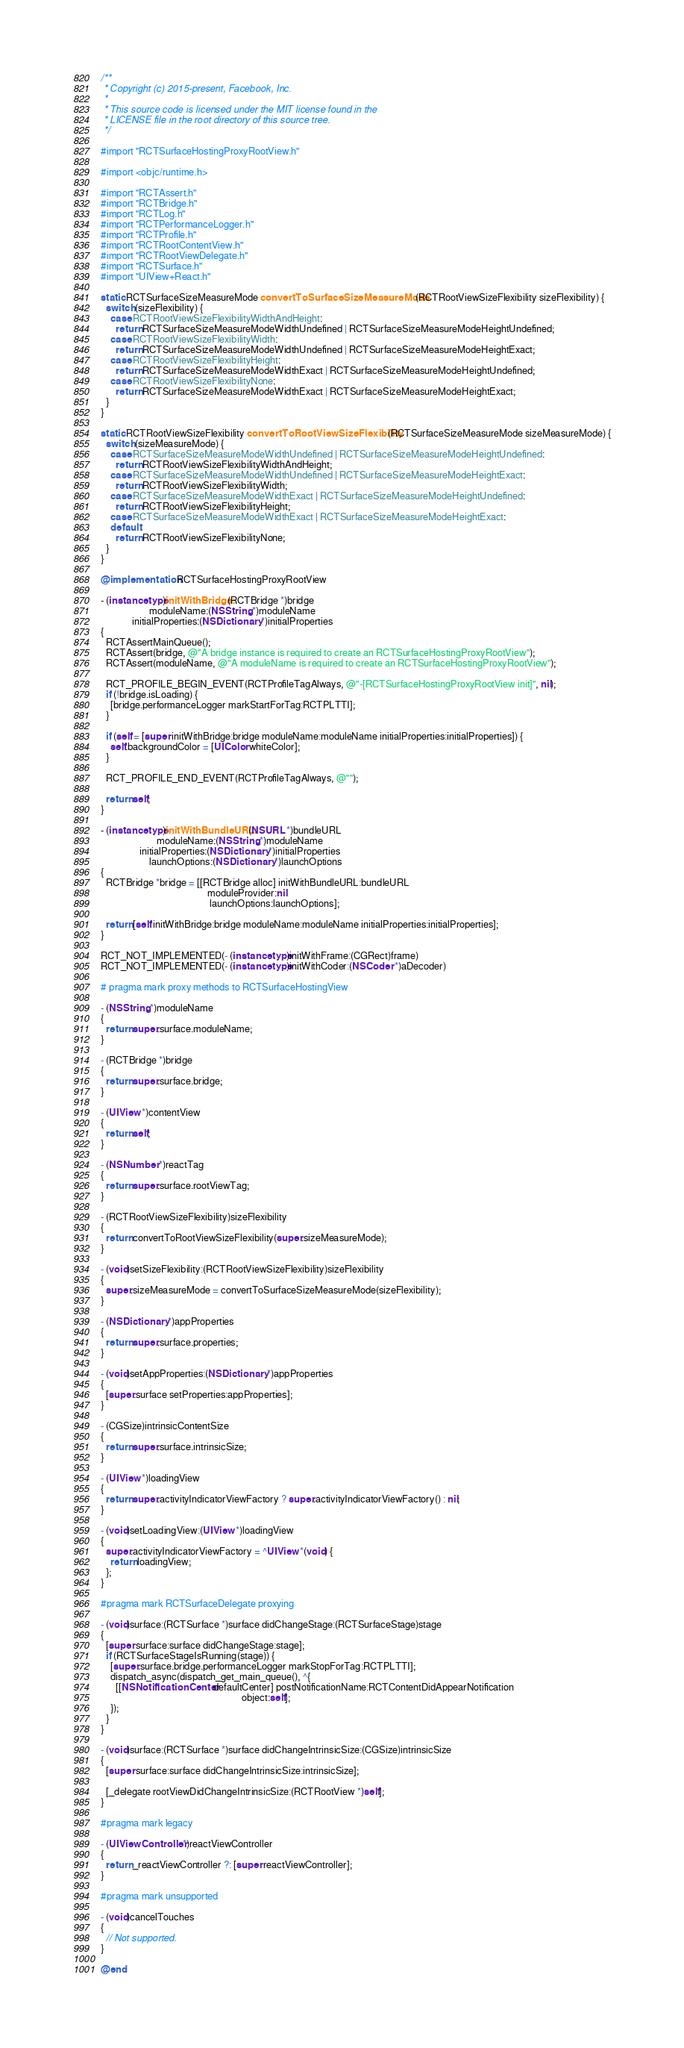<code> <loc_0><loc_0><loc_500><loc_500><_ObjectiveC_>/**
 * Copyright (c) 2015-present, Facebook, Inc.
 *
 * This source code is licensed under the MIT license found in the
 * LICENSE file in the root directory of this source tree.
 */

#import "RCTSurfaceHostingProxyRootView.h"

#import <objc/runtime.h>

#import "RCTAssert.h"
#import "RCTBridge.h"
#import "RCTLog.h"
#import "RCTPerformanceLogger.h"
#import "RCTProfile.h"
#import "RCTRootContentView.h"
#import "RCTRootViewDelegate.h"
#import "RCTSurface.h"
#import "UIView+React.h"

static RCTSurfaceSizeMeasureMode convertToSurfaceSizeMeasureMode(RCTRootViewSizeFlexibility sizeFlexibility) {
  switch (sizeFlexibility) {
    case RCTRootViewSizeFlexibilityWidthAndHeight:
      return RCTSurfaceSizeMeasureModeWidthUndefined | RCTSurfaceSizeMeasureModeHeightUndefined;
    case RCTRootViewSizeFlexibilityWidth:
      return RCTSurfaceSizeMeasureModeWidthUndefined | RCTSurfaceSizeMeasureModeHeightExact;
    case RCTRootViewSizeFlexibilityHeight:
      return RCTSurfaceSizeMeasureModeWidthExact | RCTSurfaceSizeMeasureModeHeightUndefined;
    case RCTRootViewSizeFlexibilityNone:
      return RCTSurfaceSizeMeasureModeWidthExact | RCTSurfaceSizeMeasureModeHeightExact;
  }
}

static RCTRootViewSizeFlexibility convertToRootViewSizeFlexibility(RCTSurfaceSizeMeasureMode sizeMeasureMode) {
  switch (sizeMeasureMode) {
    case RCTSurfaceSizeMeasureModeWidthUndefined | RCTSurfaceSizeMeasureModeHeightUndefined:
      return RCTRootViewSizeFlexibilityWidthAndHeight;
    case RCTSurfaceSizeMeasureModeWidthUndefined | RCTSurfaceSizeMeasureModeHeightExact:
      return RCTRootViewSizeFlexibilityWidth;
    case RCTSurfaceSizeMeasureModeWidthExact | RCTSurfaceSizeMeasureModeHeightUndefined:
      return RCTRootViewSizeFlexibilityHeight;
    case RCTSurfaceSizeMeasureModeWidthExact | RCTSurfaceSizeMeasureModeHeightExact:
    default:
      return RCTRootViewSizeFlexibilityNone;
  }
}

@implementation RCTSurfaceHostingProxyRootView

- (instancetype)initWithBridge:(RCTBridge *)bridge
                    moduleName:(NSString *)moduleName
             initialProperties:(NSDictionary *)initialProperties
{
  RCTAssertMainQueue();
  RCTAssert(bridge, @"A bridge instance is required to create an RCTSurfaceHostingProxyRootView");
  RCTAssert(moduleName, @"A moduleName is required to create an RCTSurfaceHostingProxyRootView");

  RCT_PROFILE_BEGIN_EVENT(RCTProfileTagAlways, @"-[RCTSurfaceHostingProxyRootView init]", nil);
  if (!bridge.isLoading) {
    [bridge.performanceLogger markStartForTag:RCTPLTTI];
  }

  if (self = [super initWithBridge:bridge moduleName:moduleName initialProperties:initialProperties]) {
    self.backgroundColor = [UIColor whiteColor];
  }

  RCT_PROFILE_END_EVENT(RCTProfileTagAlways, @"");

  return self;
}

- (instancetype)initWithBundleURL:(NSURL *)bundleURL
                       moduleName:(NSString *)moduleName
                initialProperties:(NSDictionary *)initialProperties
                    launchOptions:(NSDictionary *)launchOptions
{
  RCTBridge *bridge = [[RCTBridge alloc] initWithBundleURL:bundleURL
                                            moduleProvider:nil
                                             launchOptions:launchOptions];

  return [self initWithBridge:bridge moduleName:moduleName initialProperties:initialProperties];
}

RCT_NOT_IMPLEMENTED(- (instancetype)initWithFrame:(CGRect)frame)
RCT_NOT_IMPLEMENTED(- (instancetype)initWithCoder:(NSCoder *)aDecoder)

# pragma mark proxy methods to RCTSurfaceHostingView

- (NSString *)moduleName
{
  return super.surface.moduleName;
}

- (RCTBridge *)bridge
{
  return super.surface.bridge;
}

- (UIView *)contentView
{
  return self;
}

- (NSNumber *)reactTag
{
  return super.surface.rootViewTag;
}

- (RCTRootViewSizeFlexibility)sizeFlexibility
{
  return convertToRootViewSizeFlexibility(super.sizeMeasureMode);
}

- (void)setSizeFlexibility:(RCTRootViewSizeFlexibility)sizeFlexibility
{
  super.sizeMeasureMode = convertToSurfaceSizeMeasureMode(sizeFlexibility);
}

- (NSDictionary *)appProperties
{
  return super.surface.properties;
}

- (void)setAppProperties:(NSDictionary *)appProperties
{
  [super.surface setProperties:appProperties];
}

- (CGSize)intrinsicContentSize
{
  return super.surface.intrinsicSize;
}

- (UIView *)loadingView
{
  return super.activityIndicatorViewFactory ? super.activityIndicatorViewFactory() : nil;
}

- (void)setLoadingView:(UIView *)loadingView
{
  super.activityIndicatorViewFactory = ^UIView *(void) {
    return loadingView;
  };
}

#pragma mark RCTSurfaceDelegate proxying

- (void)surface:(RCTSurface *)surface didChangeStage:(RCTSurfaceStage)stage
{
  [super surface:surface didChangeStage:stage];
  if (RCTSurfaceStageIsRunning(stage)) {
    [super.surface.bridge.performanceLogger markStopForTag:RCTPLTTI];
    dispatch_async(dispatch_get_main_queue(), ^{
      [[NSNotificationCenter defaultCenter] postNotificationName:RCTContentDidAppearNotification
                                                          object:self];
    });
  }
}

- (void)surface:(RCTSurface *)surface didChangeIntrinsicSize:(CGSize)intrinsicSize
{
  [super surface:surface didChangeIntrinsicSize:intrinsicSize];

  [_delegate rootViewDidChangeIntrinsicSize:(RCTRootView *)self];
}

#pragma mark legacy

- (UIViewController *)reactViewController
{
  return _reactViewController ?: [super reactViewController];
}

#pragma mark unsupported

- (void)cancelTouches
{
  // Not supported.
}

@end

</code> 